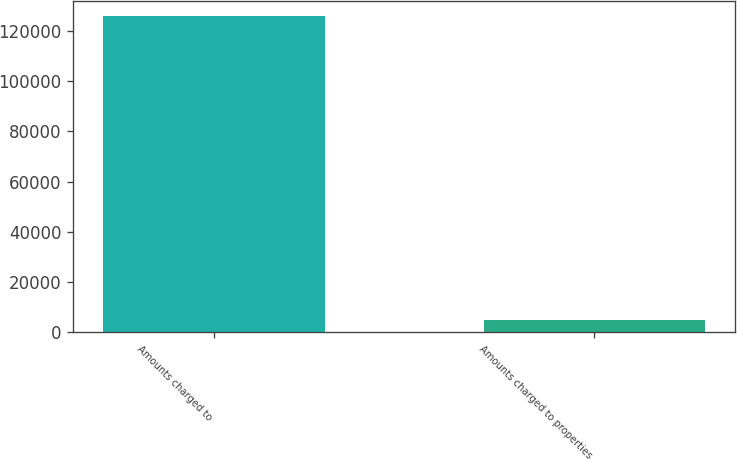Convert chart. <chart><loc_0><loc_0><loc_500><loc_500><bar_chart><fcel>Amounts charged to<fcel>Amounts charged to properties<nl><fcel>125663<fcel>4980<nl></chart> 